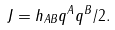Convert formula to latex. <formula><loc_0><loc_0><loc_500><loc_500>J = h _ { A B } q ^ { A } q ^ { B } / 2 .</formula> 